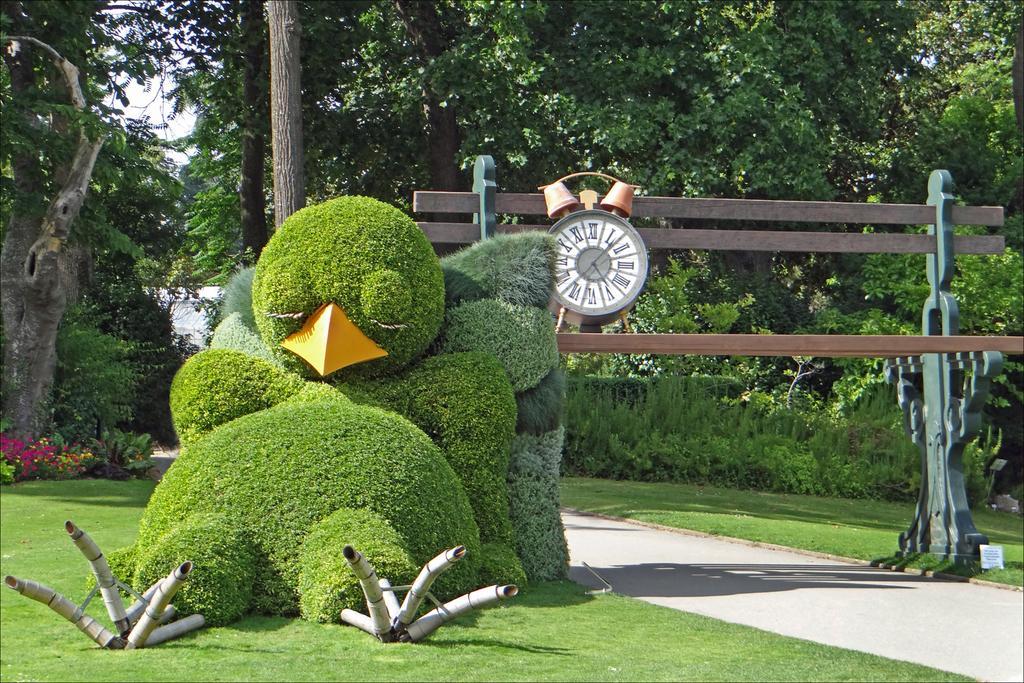Could you give a brief overview of what you see in this image? In the center of the image we can see one bird made of plants, pipes and a few other objects. In the background, we can see trees, plants, grass, one bench, wall clock and a few other objects. 